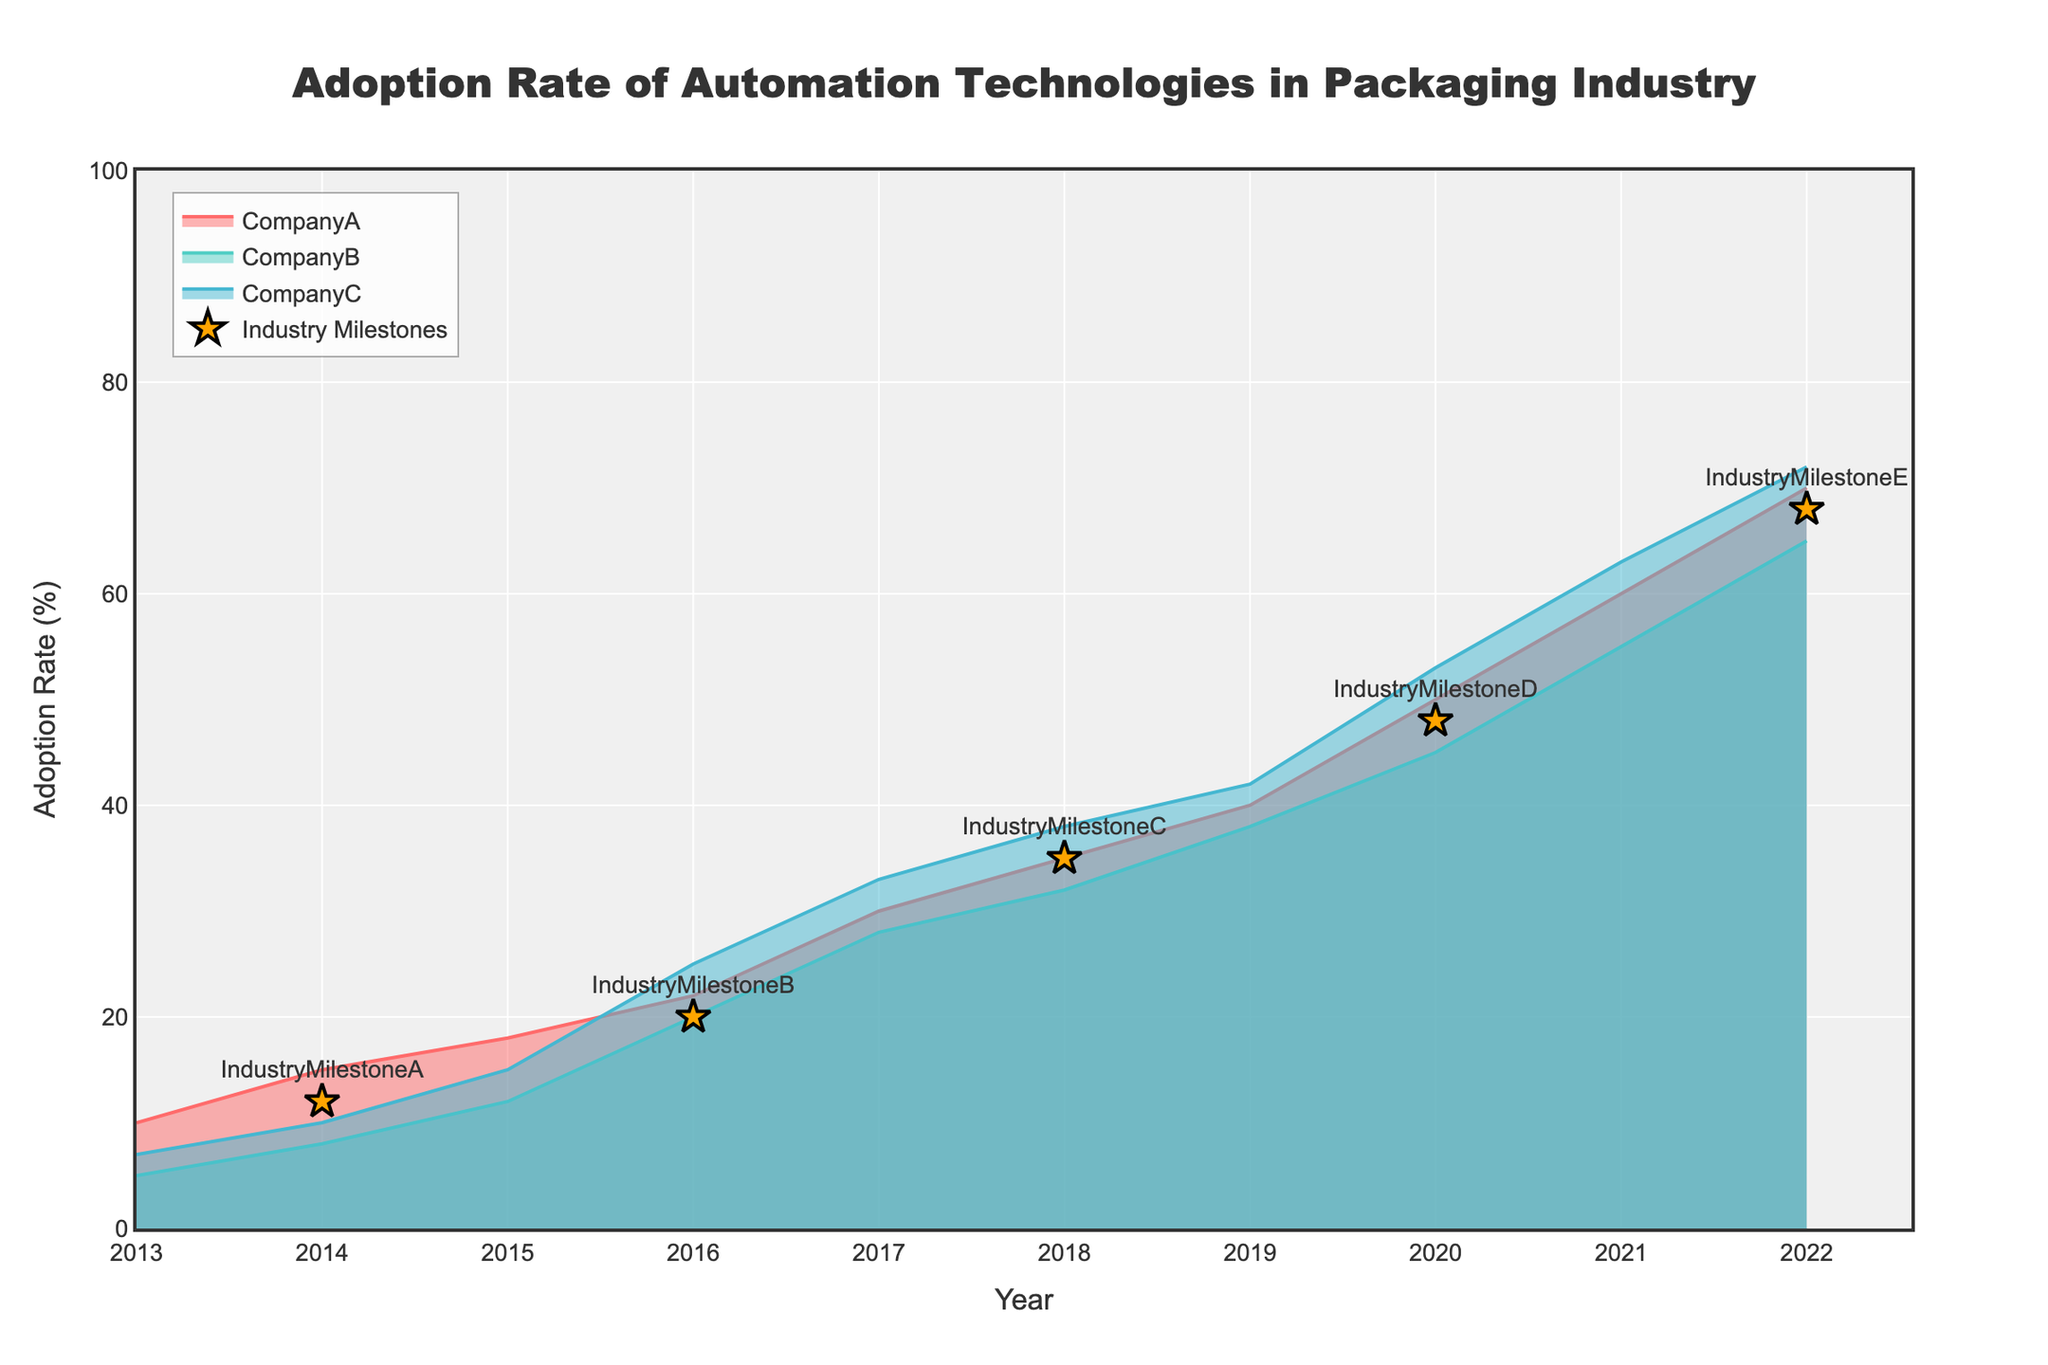What is the title of the chart? The title is displayed at the top center of the chart.
Answer: Adoption Rate of Automation Technologies in Packaging Industry What is the adoption rate of CompanyA in the year 2020? Look at the curve corresponding to CompanyA and find the data point for the year 2020.
Answer: 50% Comparing CompanyB and CompanyC, which company reached a 50% adoption rate faster? Identify the years in which both companies reached 50% adoption rate and compare them. CompanyB reached 50% in 2021, and CompanyC reached 50% in 2020.
Answer: CompanyC What are the years of the Industry Milestones marked on the chart? Look for the markers labeled as Industry Milestones on the chart and note down their years.
Answer: 2014, 2016, 2018, 2020, 2022 Which company had the highest adoption rate in 2015? Compare the adoption rates of CompanyA, CompanyB, and CompanyC in the year 2015. CompanyA: 18%, CompanyB: 12%, CompanyC: 15%.
Answer: CompanyA What was the overall trend in adoption rates for all companies over the decade? Observe the progression of the lines for each company from 2013 to 2022. All lines show an upward trend.
Answer: Increasing Which year shows the highest increase in adoption rate for CompanyA between consecutive years? Calculate the difference in adoption rate for CompanyA between consecutive years and find the maximum difference. The differences are:
2014: 5%, 2015: 3%, 2016: 4%, 2017: 8%, 2018: 5%, 2019: 5%, 2020: 10%, 2021: 10%, 2022: 10%.
Answer: 2020 Does any company have an adoption rate of exactly 60%? Look for the data points across all companies at 60%. Only CompanyA and CompanyC have points at 60%.
Answer: Yes What was the adoption rate of CompanyC in 2018, and how does it compare to Industry Milestone C? Check the adoption rate of CompanyC in 2018 and compare it with the milestone marked in the same year. Both have the same adoption rate of 38%.
Answer: 38%, same as Industry Milestone C In which year did all companies cross the 40% adoption rate? Identify the earliest year in which the adoption rate for CompanyA, CompanyB, and CompanyC are all above 40%. This happens in 2019.
Answer: 2019 